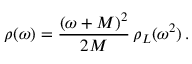<formula> <loc_0><loc_0><loc_500><loc_500>\rho ( \omega ) = \frac { ( \omega + M ) ^ { 2 } } { 2 M } \, \rho _ { L } ( \omega ^ { 2 } ) \, .</formula> 